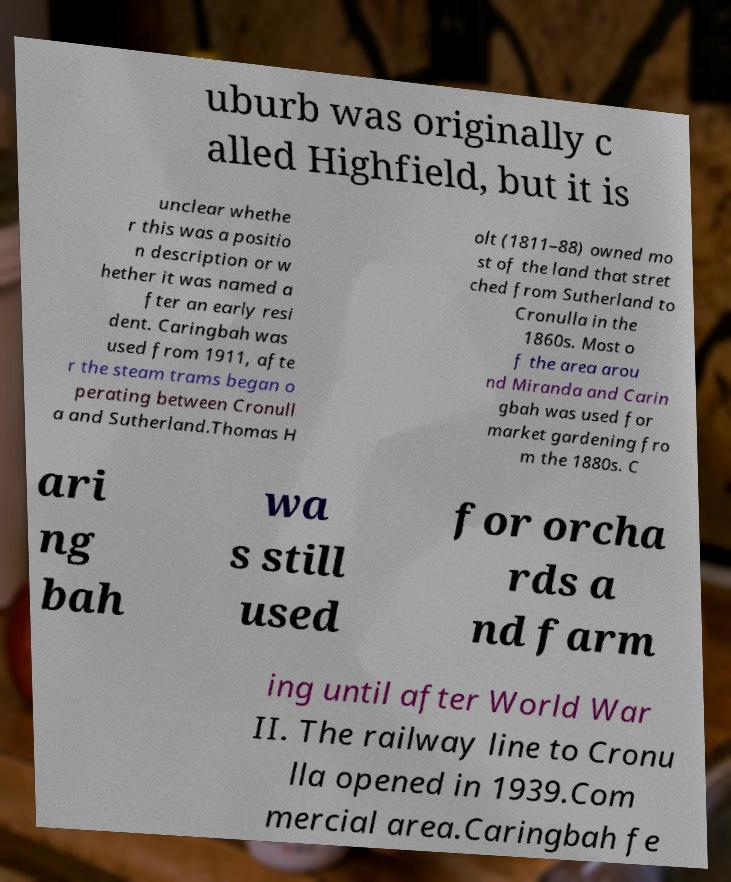What messages or text are displayed in this image? I need them in a readable, typed format. uburb was originally c alled Highfield, but it is unclear whethe r this was a positio n description or w hether it was named a fter an early resi dent. Caringbah was used from 1911, afte r the steam trams began o perating between Cronull a and Sutherland.Thomas H olt (1811–88) owned mo st of the land that stret ched from Sutherland to Cronulla in the 1860s. Most o f the area arou nd Miranda and Carin gbah was used for market gardening fro m the 1880s. C ari ng bah wa s still used for orcha rds a nd farm ing until after World War II. The railway line to Cronu lla opened in 1939.Com mercial area.Caringbah fe 